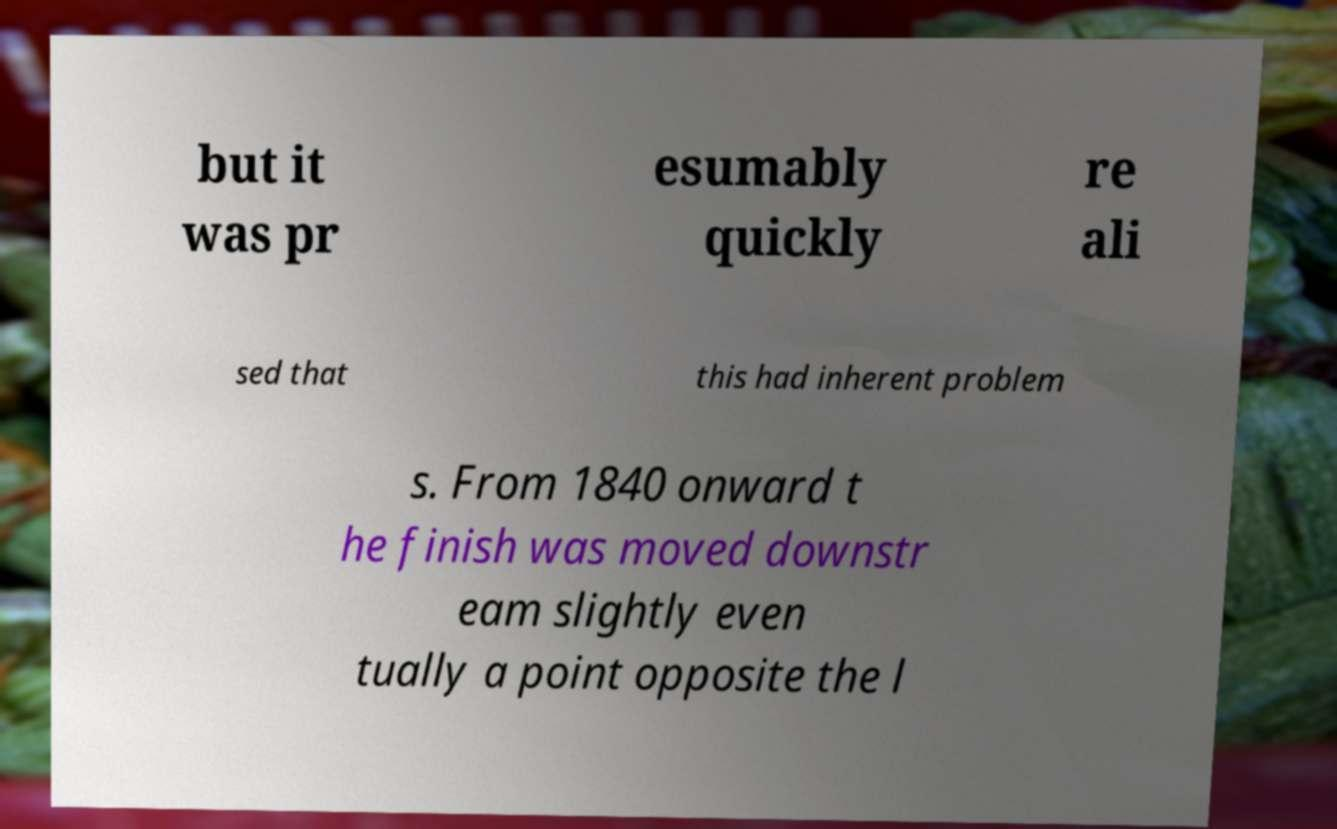Please identify and transcribe the text found in this image. but it was pr esumably quickly re ali sed that this had inherent problem s. From 1840 onward t he finish was moved downstr eam slightly even tually a point opposite the l 